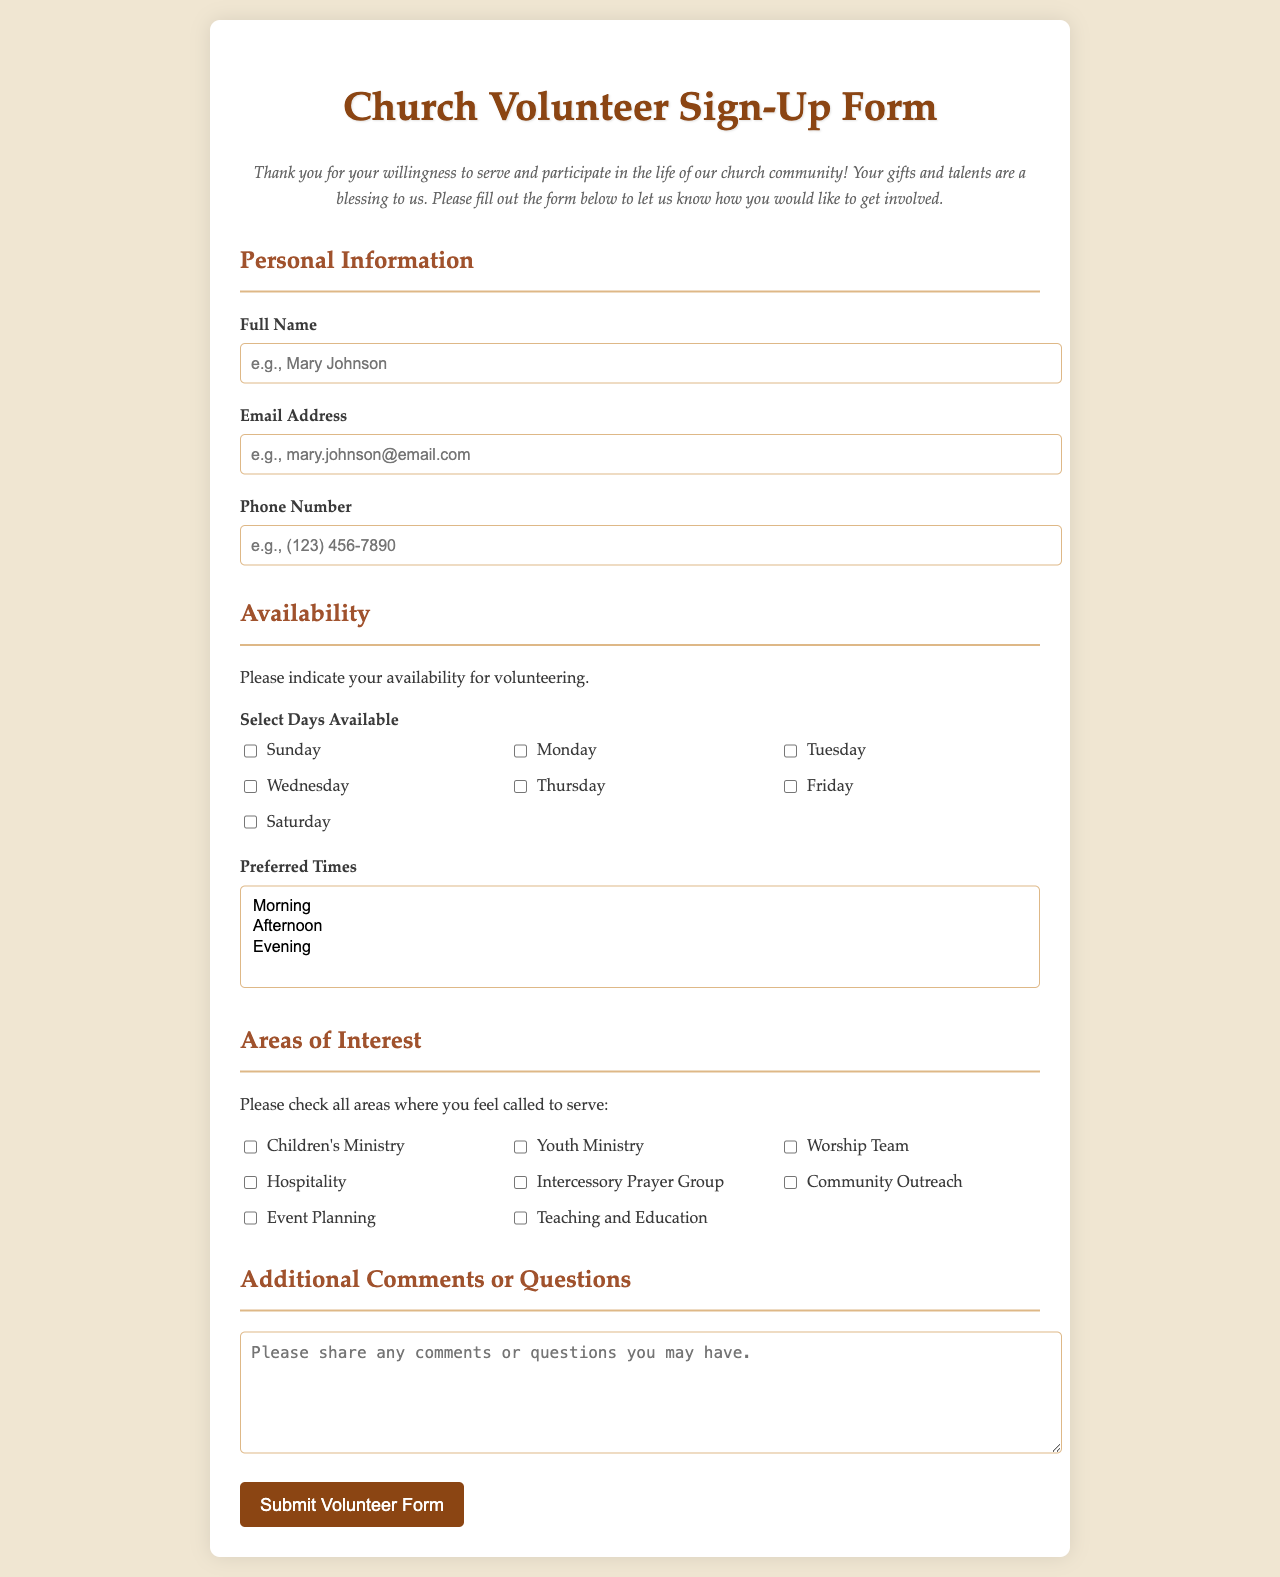what is the title of the form? The title of the form is prominently displayed at the top of the document, clearly indicating the purpose of the form.
Answer: Church Volunteer Sign-Up Form who is the intended audience for this form? The form is designed for individuals who are interested in getting involved and volunteering within the church community.
Answer: Volunteers how many sections are in the form? The structure of the document indicates that there are multiple sections to fill out with specific information required from the volunteers.
Answer: Four what are the days available for volunteering? The form includes a list of specific days for which users can express their availability to volunteer.
Answer: Sunday, Monday, Tuesday, Wednesday, Thursday, Friday, Saturday which area of interest is explicitly related to prayer? The document lists various areas where individuals can express their willingness to serve; one of them specifically relates to prayer ministries.
Answer: Intercessory Prayer Group how many preferred times can be selected in the availability section? The selection box allows users to choose multiple options regarding their preferred times for volunteering, showing flexibility in availability.
Answer: Three what type of feedback can users leave in the comments section? The form provides a dedicated area for users to express any additional thoughts, feelings, or inquiries they may have.
Answer: Comments or questions what is the color theme used in the document? The design elements suggest a warm and inviting atmosphere, with colors that reflect a nurturing environment suitable for a church community.
Answer: Earth tones what action can users take after filling out the form? The final button at the bottom of the form enables users to submit the information they've entered, indicating their commitment to volunteer.
Answer: Submit Volunteer Form 